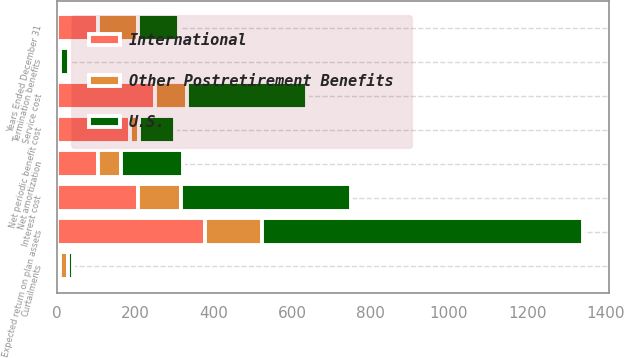<chart> <loc_0><loc_0><loc_500><loc_500><stacked_bar_chart><ecel><fcel>Years Ended December 31<fcel>Service cost<fcel>Interest cost<fcel>Expected return on plan assets<fcel>Net amortization<fcel>Termination benefits<fcel>Curtailments<fcel>Net periodic benefit cost<nl><fcel>U.S.<fcel>104<fcel>307<fcel>434<fcel>819<fcel>158<fcel>22<fcel>12<fcel>91<nl><fcel>International<fcel>104<fcel>251<fcel>206<fcel>379<fcel>104<fcel>1<fcel>9<fcel>186<nl><fcel>Other Postretirement Benefits<fcel>104<fcel>80<fcel>110<fcel>143<fcel>59<fcel>7<fcel>19<fcel>24<nl></chart> 